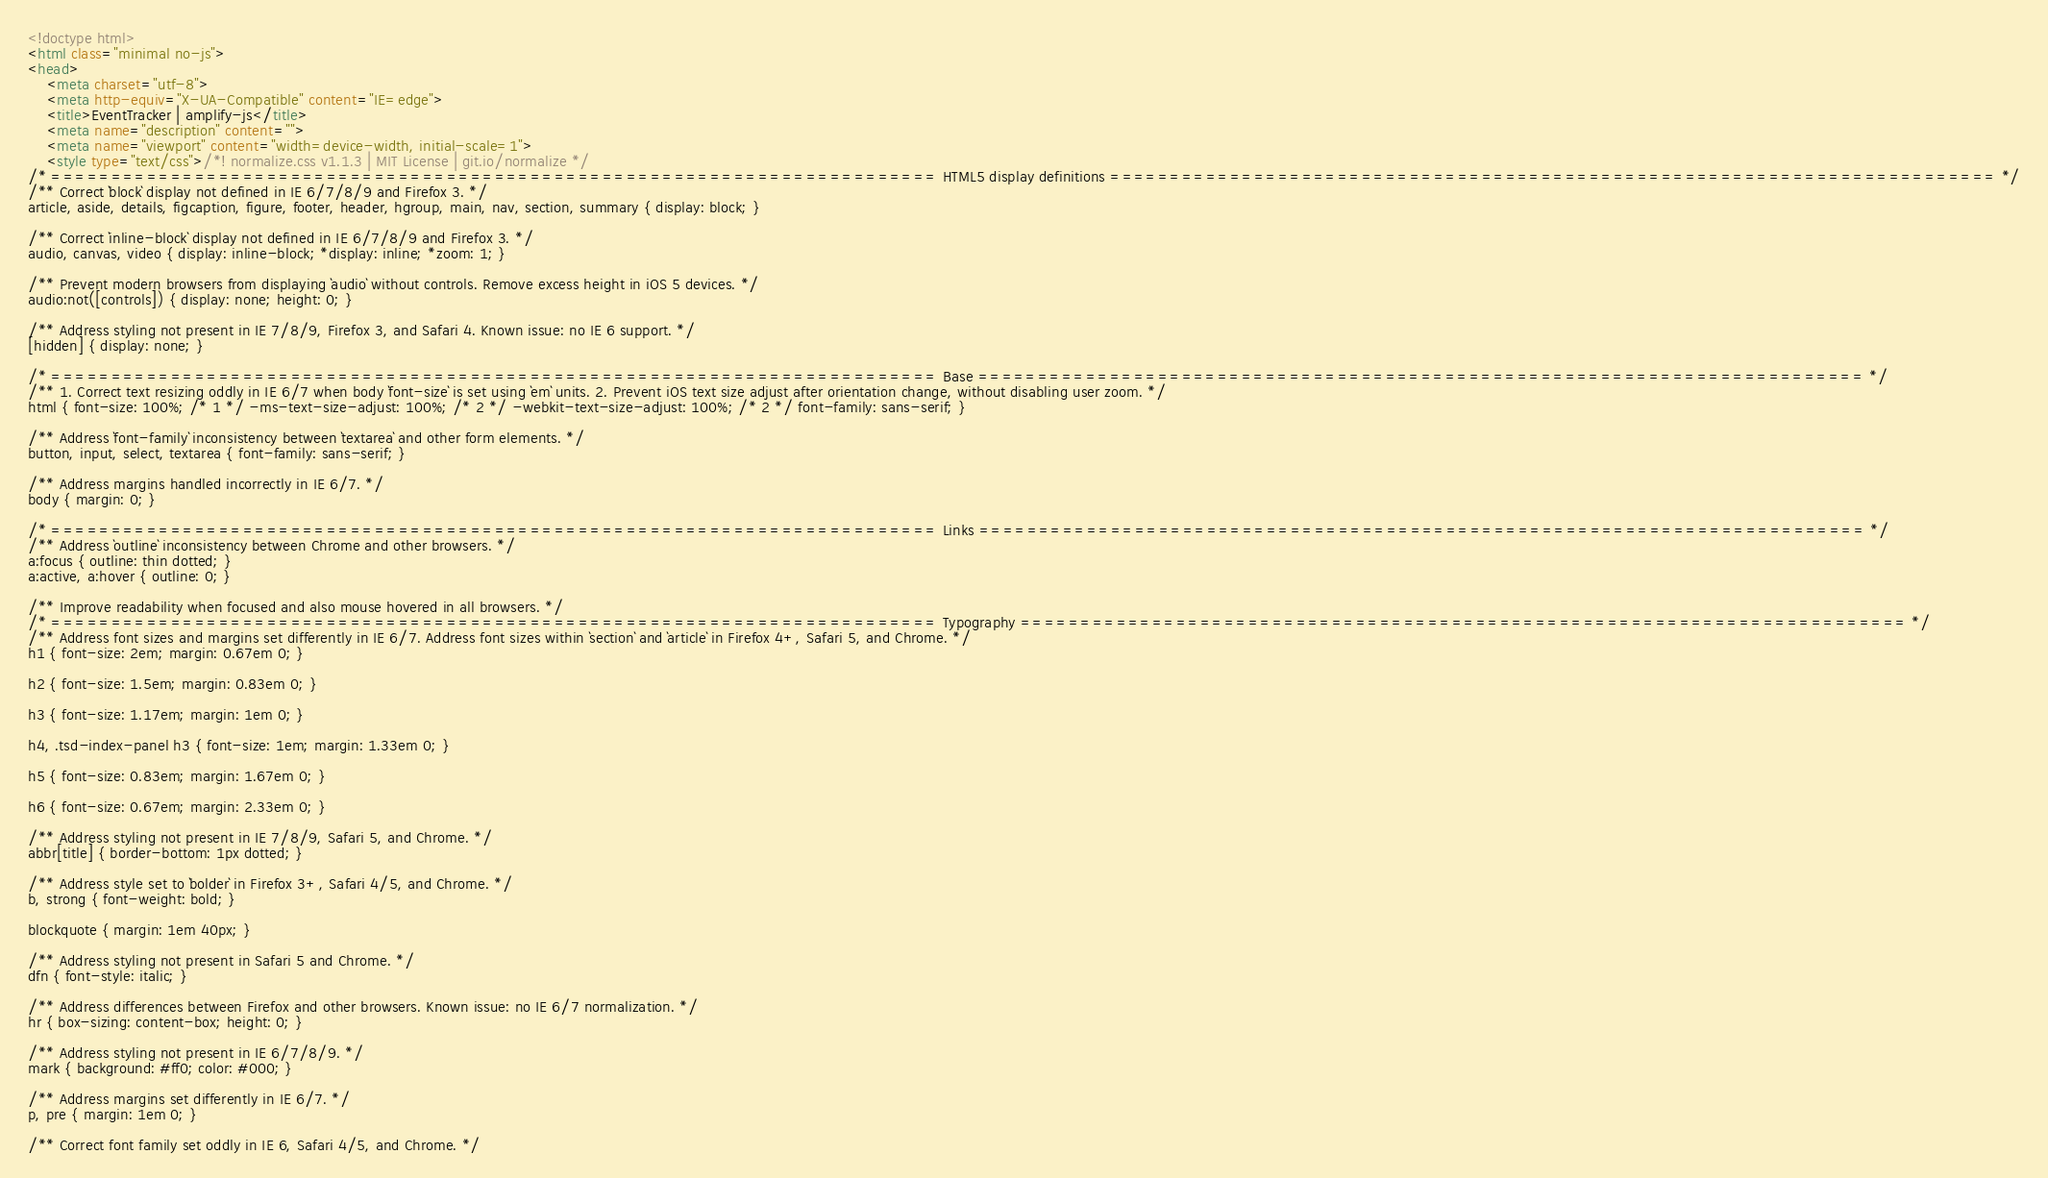<code> <loc_0><loc_0><loc_500><loc_500><_HTML_><!doctype html>
<html class="minimal no-js">
<head>
	<meta charset="utf-8">
	<meta http-equiv="X-UA-Compatible" content="IE=edge">
	<title>EventTracker | amplify-js</title>
	<meta name="description" content="">
	<meta name="viewport" content="width=device-width, initial-scale=1">
	<style type="text/css">/*! normalize.css v1.1.3 | MIT License | git.io/normalize */
/* ========================================================================== HTML5 display definitions ========================================================================== */
/** Correct `block` display not defined in IE 6/7/8/9 and Firefox 3. */
article, aside, details, figcaption, figure, footer, header, hgroup, main, nav, section, summary { display: block; }

/** Correct `inline-block` display not defined in IE 6/7/8/9 and Firefox 3. */
audio, canvas, video { display: inline-block; *display: inline; *zoom: 1; }

/** Prevent modern browsers from displaying `audio` without controls. Remove excess height in iOS 5 devices. */
audio:not([controls]) { display: none; height: 0; }

/** Address styling not present in IE 7/8/9, Firefox 3, and Safari 4. Known issue: no IE 6 support. */
[hidden] { display: none; }

/* ========================================================================== Base ========================================================================== */
/** 1. Correct text resizing oddly in IE 6/7 when body `font-size` is set using `em` units. 2. Prevent iOS text size adjust after orientation change, without disabling user zoom. */
html { font-size: 100%; /* 1 */ -ms-text-size-adjust: 100%; /* 2 */ -webkit-text-size-adjust: 100%; /* 2 */ font-family: sans-serif; }

/** Address `font-family` inconsistency between `textarea` and other form elements. */
button, input, select, textarea { font-family: sans-serif; }

/** Address margins handled incorrectly in IE 6/7. */
body { margin: 0; }

/* ========================================================================== Links ========================================================================== */
/** Address `outline` inconsistency between Chrome and other browsers. */
a:focus { outline: thin dotted; }
a:active, a:hover { outline: 0; }

/** Improve readability when focused and also mouse hovered in all browsers. */
/* ========================================================================== Typography ========================================================================== */
/** Address font sizes and margins set differently in IE 6/7. Address font sizes within `section` and `article` in Firefox 4+, Safari 5, and Chrome. */
h1 { font-size: 2em; margin: 0.67em 0; }

h2 { font-size: 1.5em; margin: 0.83em 0; }

h3 { font-size: 1.17em; margin: 1em 0; }

h4, .tsd-index-panel h3 { font-size: 1em; margin: 1.33em 0; }

h5 { font-size: 0.83em; margin: 1.67em 0; }

h6 { font-size: 0.67em; margin: 2.33em 0; }

/** Address styling not present in IE 7/8/9, Safari 5, and Chrome. */
abbr[title] { border-bottom: 1px dotted; }

/** Address style set to `bolder` in Firefox 3+, Safari 4/5, and Chrome. */
b, strong { font-weight: bold; }

blockquote { margin: 1em 40px; }

/** Address styling not present in Safari 5 and Chrome. */
dfn { font-style: italic; }

/** Address differences between Firefox and other browsers. Known issue: no IE 6/7 normalization. */
hr { box-sizing: content-box; height: 0; }

/** Address styling not present in IE 6/7/8/9. */
mark { background: #ff0; color: #000; }

/** Address margins set differently in IE 6/7. */
p, pre { margin: 1em 0; }

/** Correct font family set oddly in IE 6, Safari 4/5, and Chrome. */</code> 